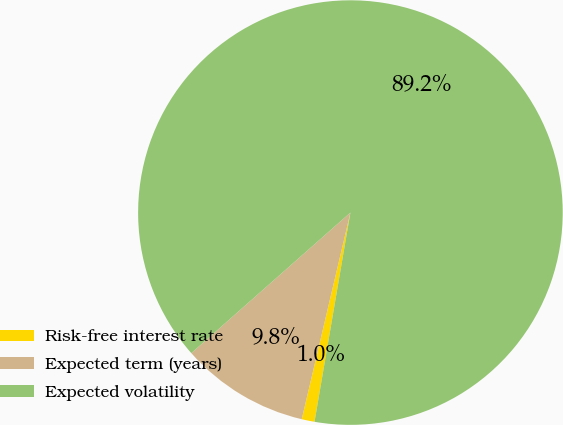Convert chart to OTSL. <chart><loc_0><loc_0><loc_500><loc_500><pie_chart><fcel>Risk-free interest rate<fcel>Expected term (years)<fcel>Expected volatility<nl><fcel>0.98%<fcel>9.8%<fcel>89.22%<nl></chart> 